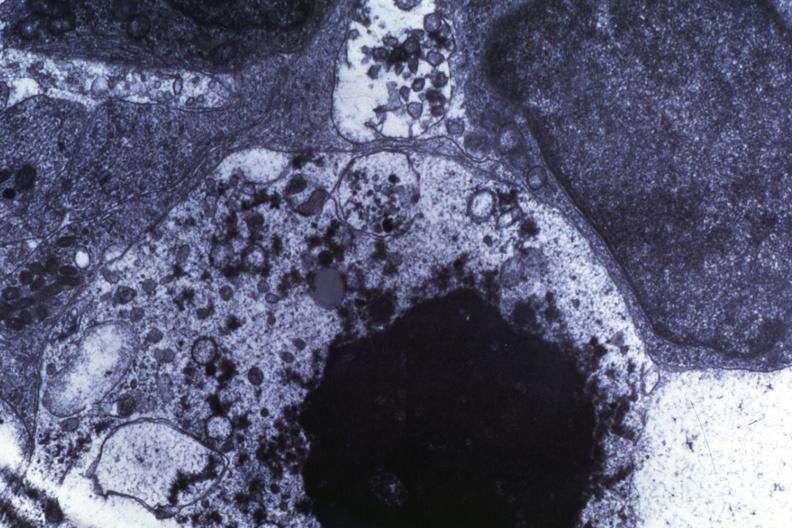s feet present?
Answer the question using a single word or phrase. No 